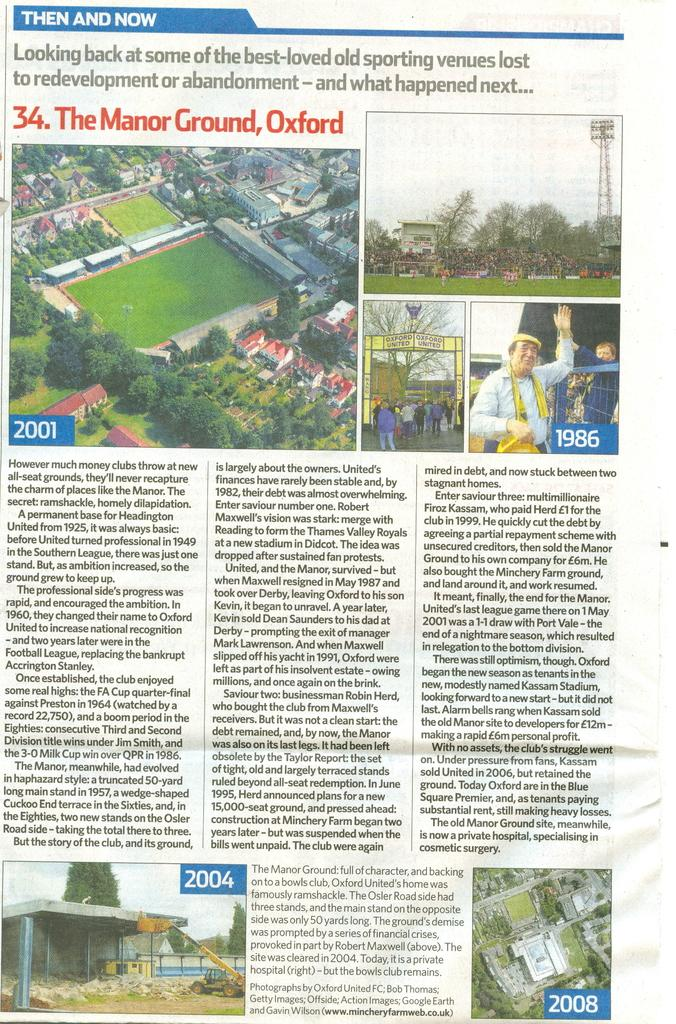What type of approval does the waste receive from the eyes in the image? There is no image, waste, or eyes mentioned, so it is not possible to answer this question. 